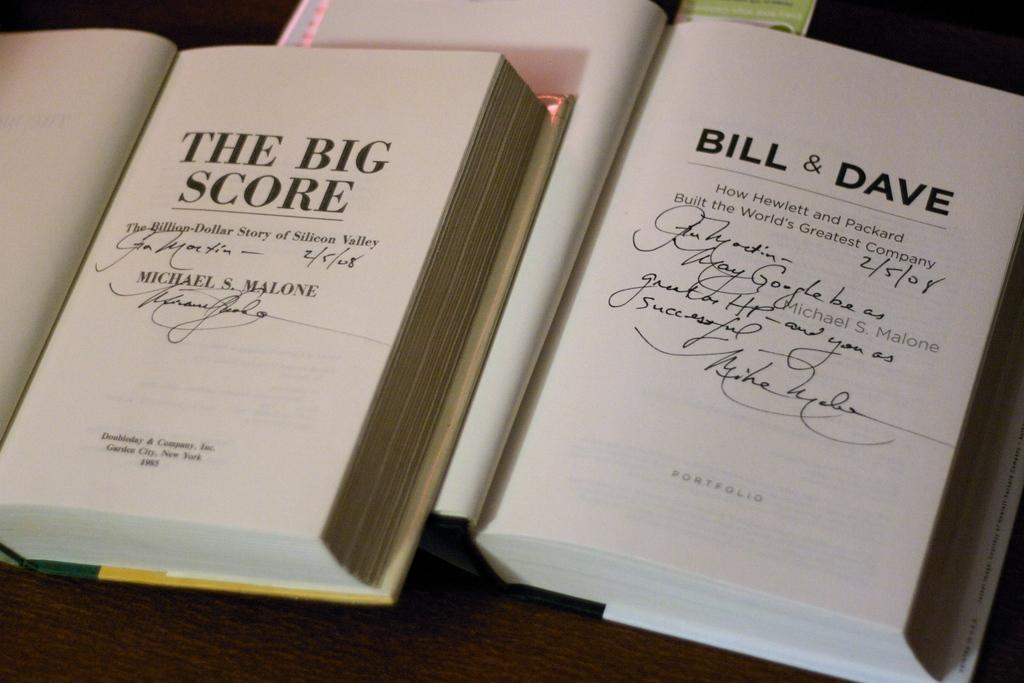Provide a one-sentence caption for the provided image. Novels with the titles of, "The Big Score" and "Bill & Dave" both have autographs signed on their first pages. 